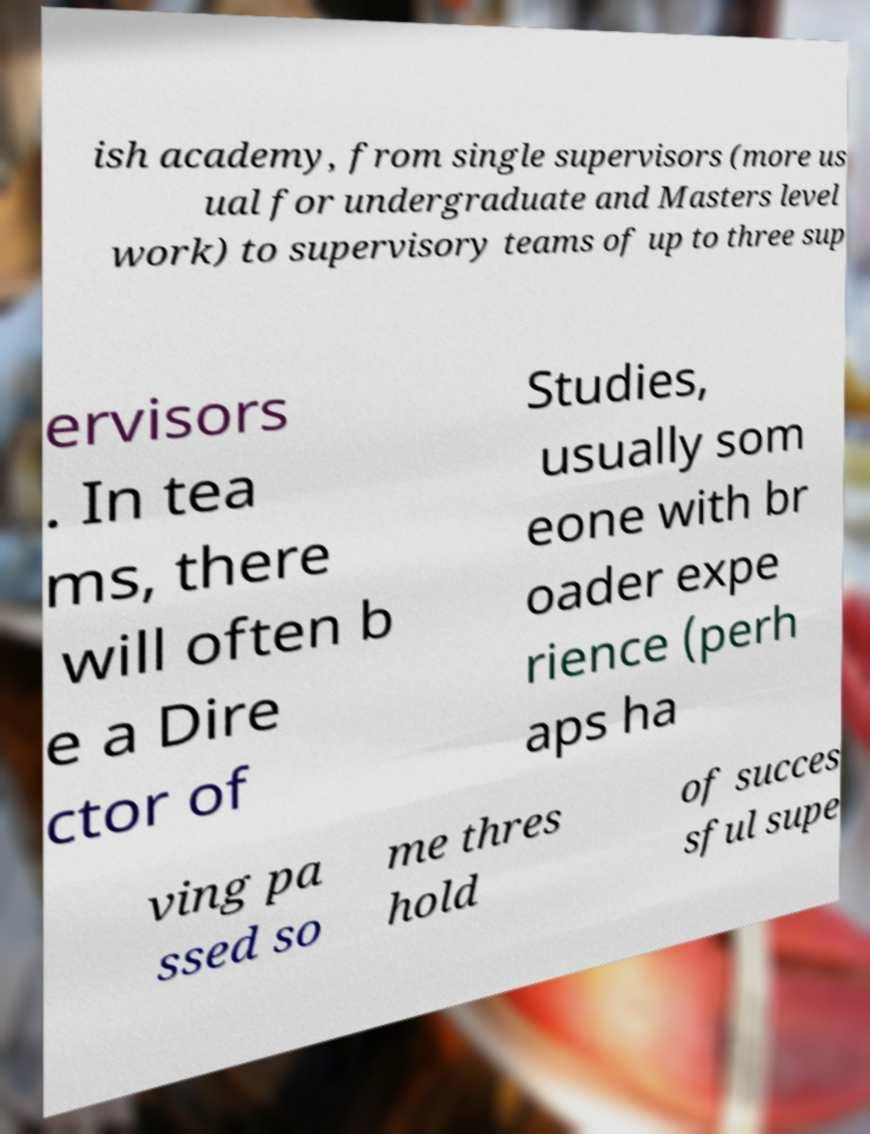There's text embedded in this image that I need extracted. Can you transcribe it verbatim? ish academy, from single supervisors (more us ual for undergraduate and Masters level work) to supervisory teams of up to three sup ervisors . In tea ms, there will often b e a Dire ctor of Studies, usually som eone with br oader expe rience (perh aps ha ving pa ssed so me thres hold of succes sful supe 